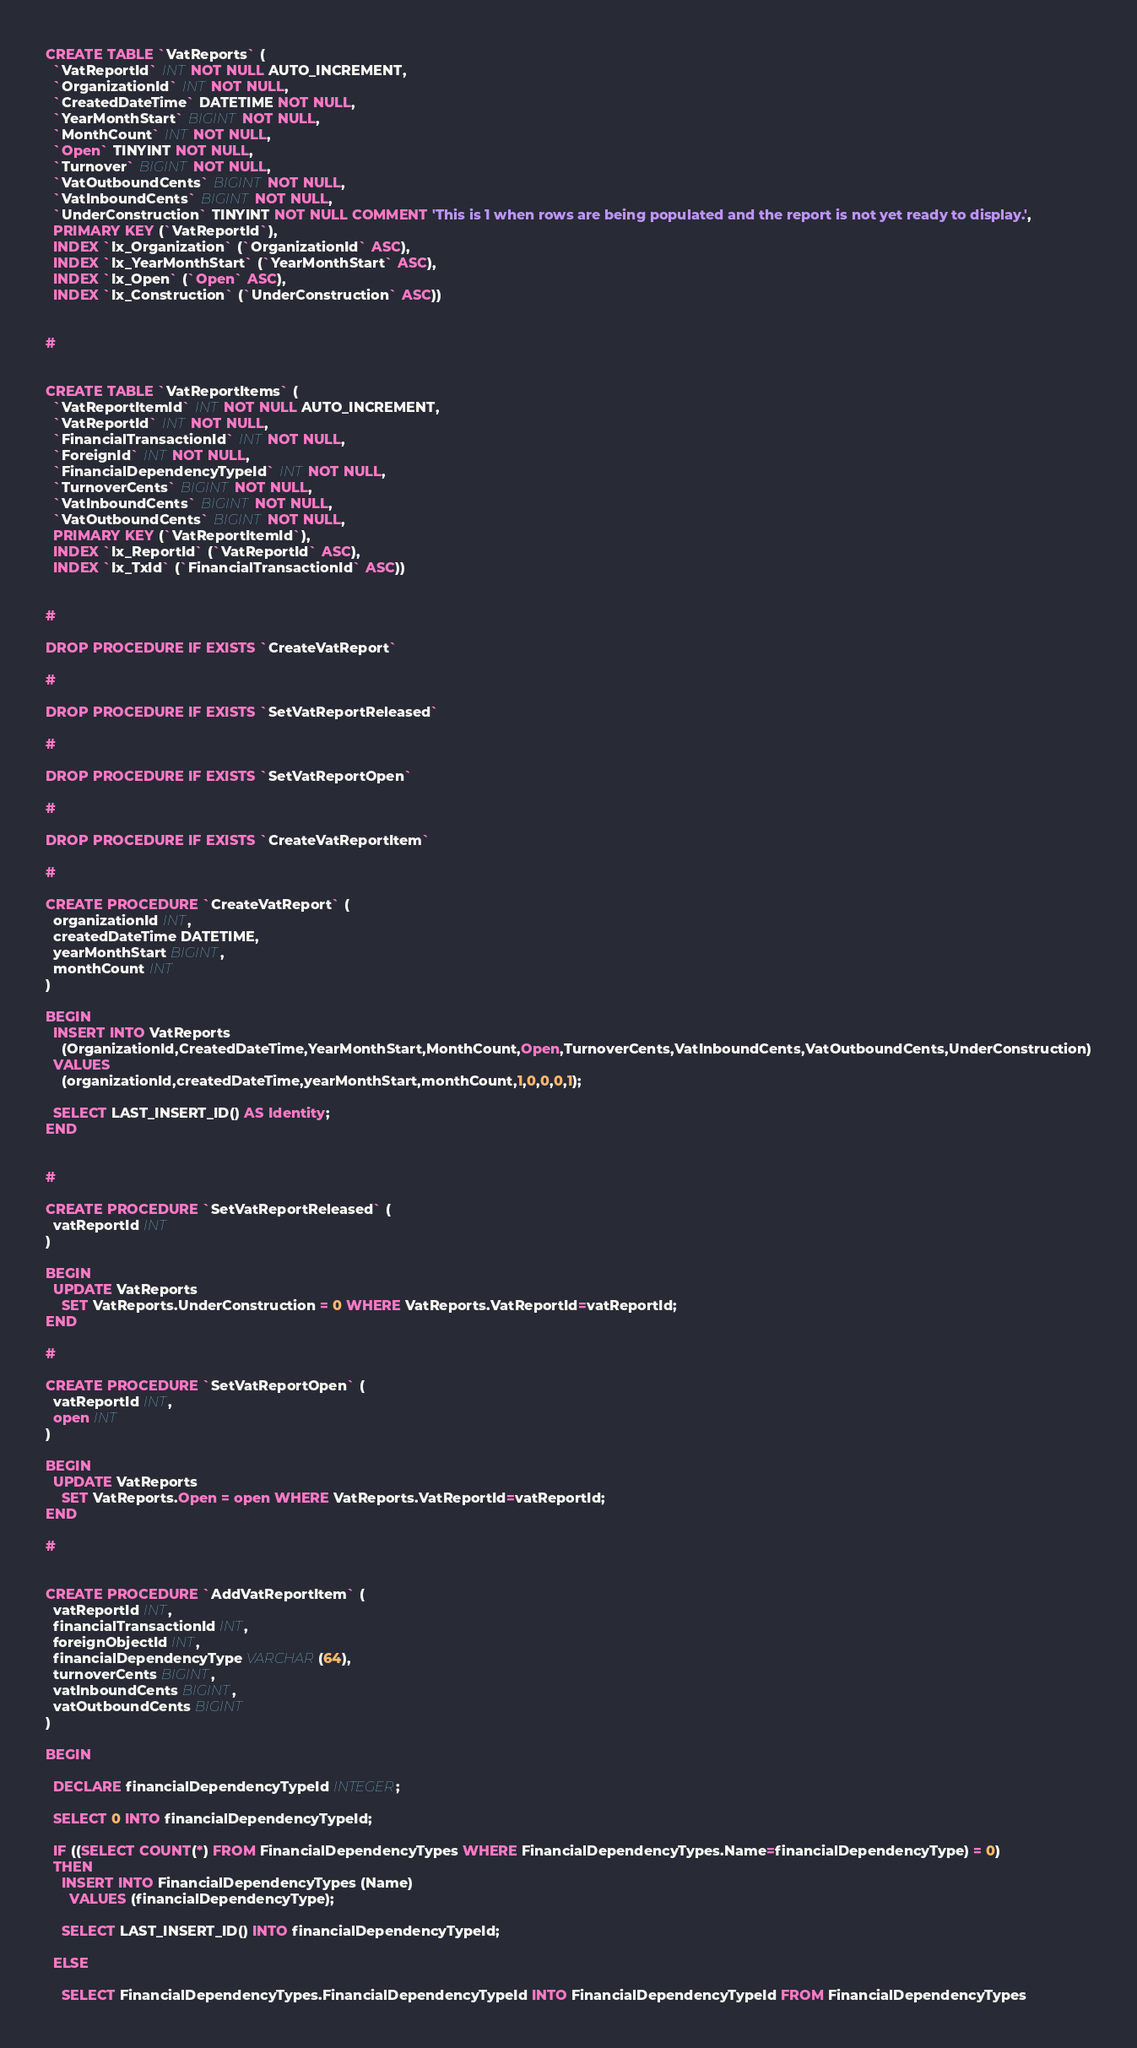Convert code to text. <code><loc_0><loc_0><loc_500><loc_500><_SQL_>CREATE TABLE `VatReports` (
  `VatReportId` INT NOT NULL AUTO_INCREMENT,
  `OrganizationId` INT NOT NULL,
  `CreatedDateTime` DATETIME NOT NULL,
  `YearMonthStart` BIGINT NOT NULL,
  `MonthCount` INT NOT NULL,
  `Open` TINYINT NOT NULL,
  `Turnover` BIGINT NOT NULL,
  `VatOutboundCents` BIGINT NOT NULL,
  `VatInboundCents` BIGINT NOT NULL,
  `UnderConstruction` TINYINT NOT NULL COMMENT 'This is 1 when rows are being populated and the report is not yet ready to display.',
  PRIMARY KEY (`VatReportId`),
  INDEX `Ix_Organization` (`OrganizationId` ASC),
  INDEX `Ix_YearMonthStart` (`YearMonthStart` ASC),
  INDEX `Ix_Open` (`Open` ASC),
  INDEX `Ix_Construction` (`UnderConstruction` ASC))


#


CREATE TABLE `VatReportItems` (
  `VatReportItemId` INT NOT NULL AUTO_INCREMENT,
  `VatReportId` INT NOT NULL,
  `FinancialTransactionId` INT NOT NULL,
  `ForeignId` INT NOT NULL,
  `FinancialDependencyTypeId` INT NOT NULL,
  `TurnoverCents` BIGINT NOT NULL,
  `VatInboundCents` BIGINT NOT NULL,
  `VatOutboundCents` BIGINT NOT NULL,
  PRIMARY KEY (`VatReportItemId`),
  INDEX `Ix_ReportId` (`VatReportId` ASC),
  INDEX `Ix_TxId` (`FinancialTransactionId` ASC))


#

DROP PROCEDURE IF EXISTS `CreateVatReport`

#

DROP PROCEDURE IF EXISTS `SetVatReportReleased`

#

DROP PROCEDURE IF EXISTS `SetVatReportOpen`

#

DROP PROCEDURE IF EXISTS `CreateVatReportItem`

#

CREATE PROCEDURE `CreateVatReport` (
  organizationId INT,
  createdDateTime DATETIME,
  yearMonthStart BIGINT,
  monthCount INT  
)

BEGIN
  INSERT INTO VatReports
    (OrganizationId,CreatedDateTime,YearMonthStart,MonthCount,Open,TurnoverCents,VatInboundCents,VatOutboundCents,UnderConstruction)
  VALUES
    (organizationId,createdDateTime,yearMonthStart,monthCount,1,0,0,0,1);
    
  SELECT LAST_INSERT_ID() AS Identity;  
END


#

CREATE PROCEDURE `SetVatReportReleased` (
  vatReportId INT
)

BEGIN
  UPDATE VatReports
    SET VatReports.UnderConstruction = 0 WHERE VatReports.VatReportId=vatReportId;
END

#

CREATE PROCEDURE `SetVatReportOpen` (
  vatReportId INT,
  open INT
)

BEGIN
  UPDATE VatReports
    SET VatReports.Open = open WHERE VatReports.VatReportId=vatReportId;
END

#


CREATE PROCEDURE `AddVatReportItem` (
  vatReportId INT,
  financialTransactionId INT,
  foreignObjectId INT,
  financialDependencyType VARCHAR(64),
  turnoverCents BIGINT,
  vatInboundCents BIGINT,
  vatOutboundCents BIGINT
)

BEGIN

  DECLARE financialDependencyTypeId INTEGER;

  SELECT 0 INTO financialDependencyTypeId;

  IF ((SELECT COUNT(*) FROM FinancialDependencyTypes WHERE FinancialDependencyTypes.Name=financialDependencyType) = 0)
  THEN
    INSERT INTO FinancialDependencyTypes (Name)
      VALUES (financialDependencyType);

    SELECT LAST_INSERT_ID() INTO financialDependencyTypeId;

  ELSE

    SELECT FinancialDependencyTypes.FinancialDependencyTypeId INTO FinancialDependencyTypeId FROM FinancialDependencyTypes</code> 